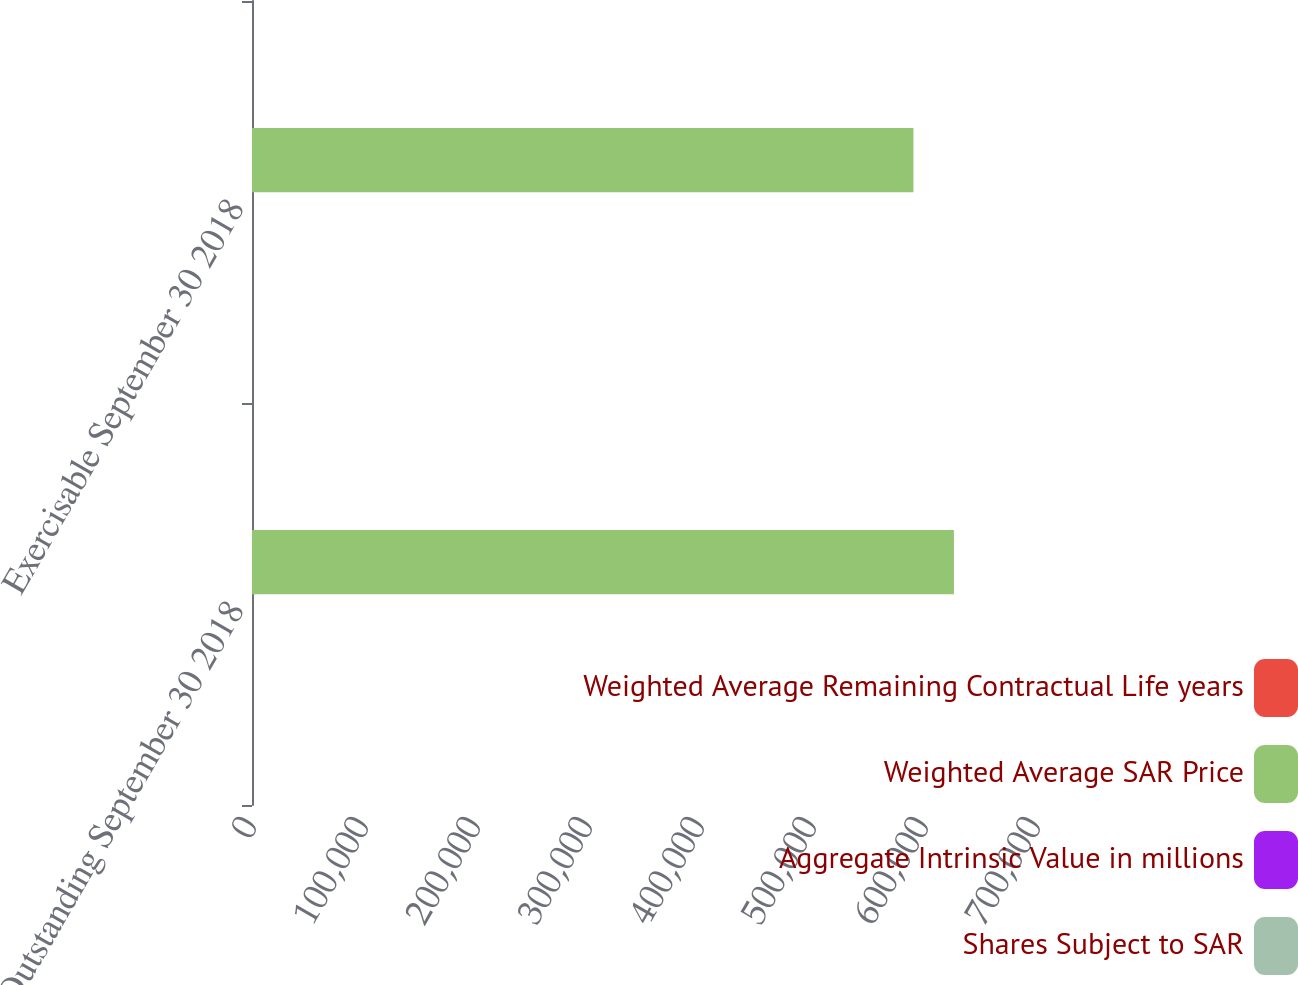<chart> <loc_0><loc_0><loc_500><loc_500><stacked_bar_chart><ecel><fcel>Outstanding September 30 2018<fcel>Exercisable September 30 2018<nl><fcel>Weighted Average Remaining Contractual Life years<fcel>27.39<fcel>26.52<nl><fcel>Weighted Average SAR Price<fcel>626701<fcel>590556<nl><fcel>Aggregate Intrinsic Value in millions<fcel>3.2<fcel>3.1<nl><fcel>Shares Subject to SAR<fcel>5<fcel>5<nl></chart> 